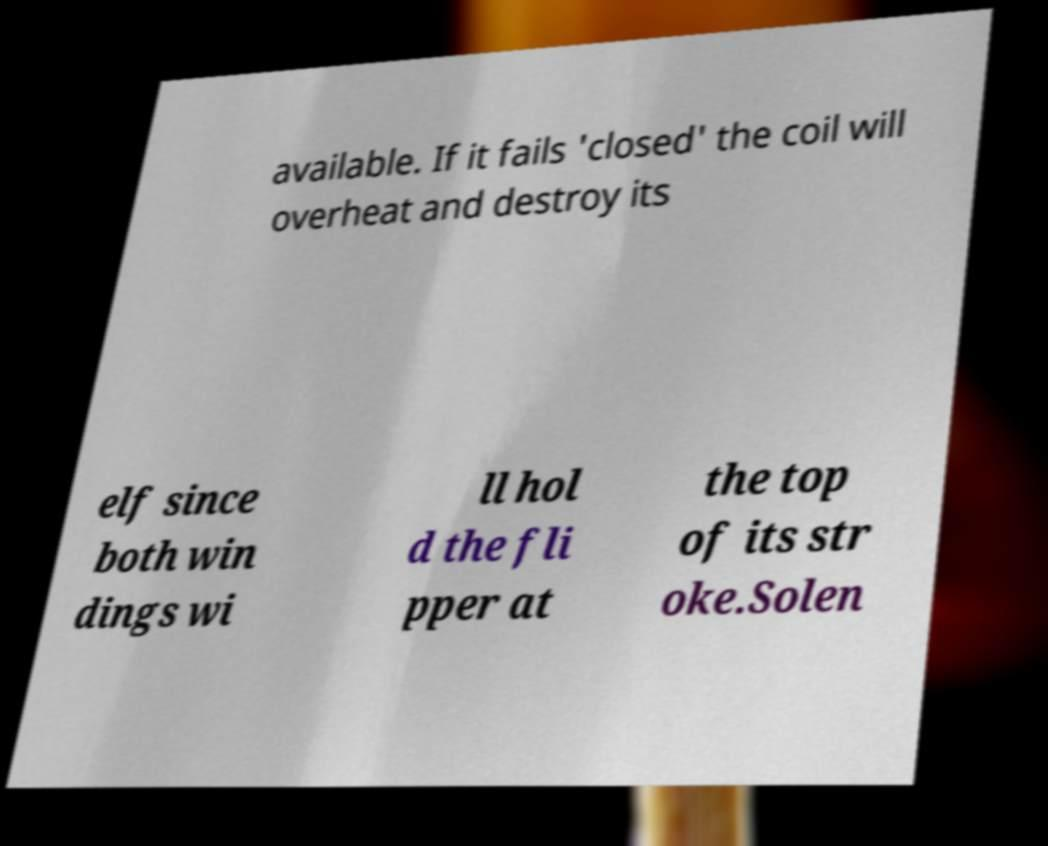Could you assist in decoding the text presented in this image and type it out clearly? available. If it fails 'closed' the coil will overheat and destroy its elf since both win dings wi ll hol d the fli pper at the top of its str oke.Solen 